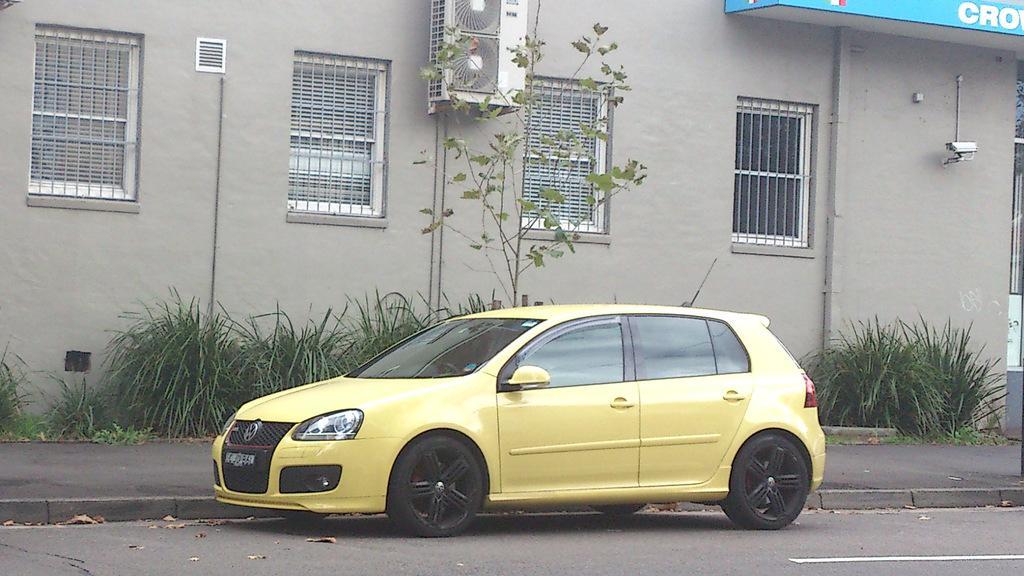Can you describe this image briefly? In the center of the image we can see a car on the road. In the background there is grass and we can see a tree. There is a building. 